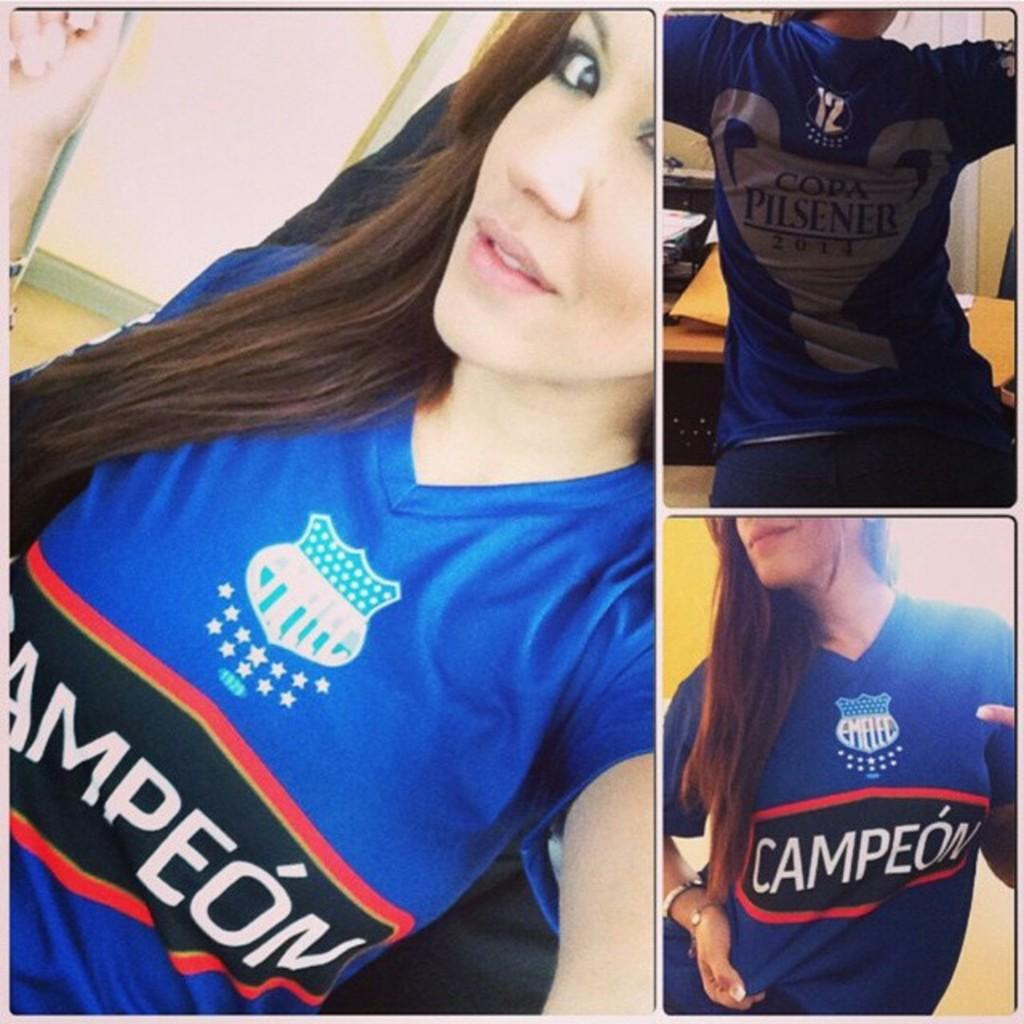<image>
Render a clear and concise summary of the photo. Woman wearing a Pilsener shirt while posing for a picture. 